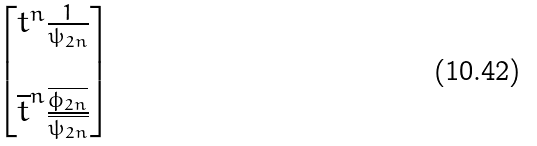Convert formula to latex. <formula><loc_0><loc_0><loc_500><loc_500>\begin{bmatrix} { t ^ { n } } \frac { 1 } { \psi _ { 2 n } } \\ \\ \overline { t } ^ { n } \frac { \overline { \phi _ { 2 n } } } { \overline { \psi _ { 2 n } } } \end{bmatrix}</formula> 